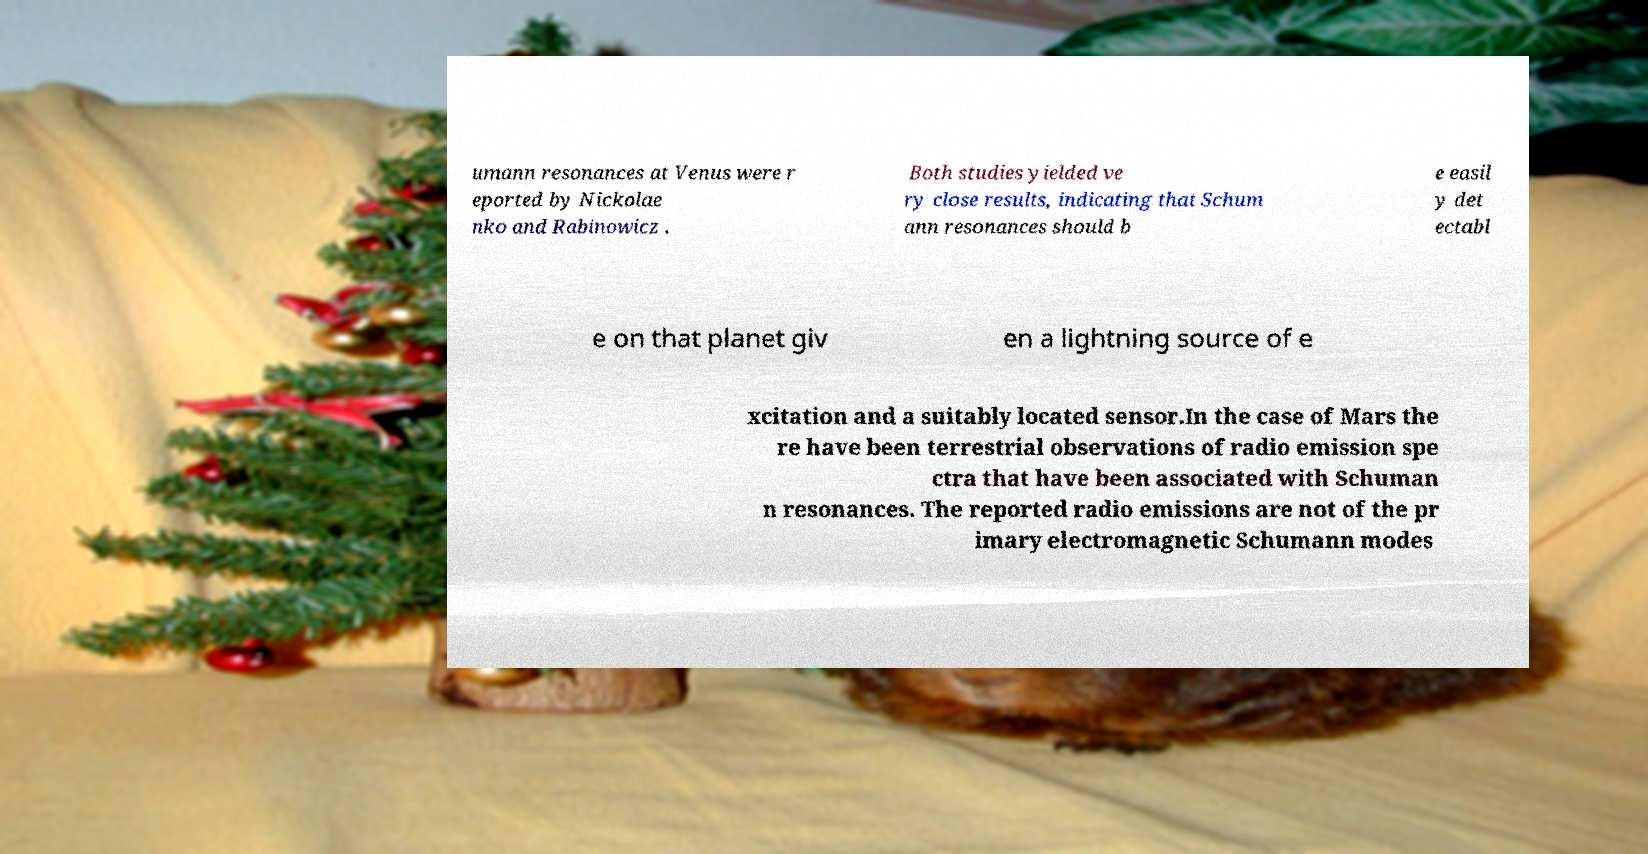Could you extract and type out the text from this image? umann resonances at Venus were r eported by Nickolae nko and Rabinowicz . Both studies yielded ve ry close results, indicating that Schum ann resonances should b e easil y det ectabl e on that planet giv en a lightning source of e xcitation and a suitably located sensor.In the case of Mars the re have been terrestrial observations of radio emission spe ctra that have been associated with Schuman n resonances. The reported radio emissions are not of the pr imary electromagnetic Schumann modes 